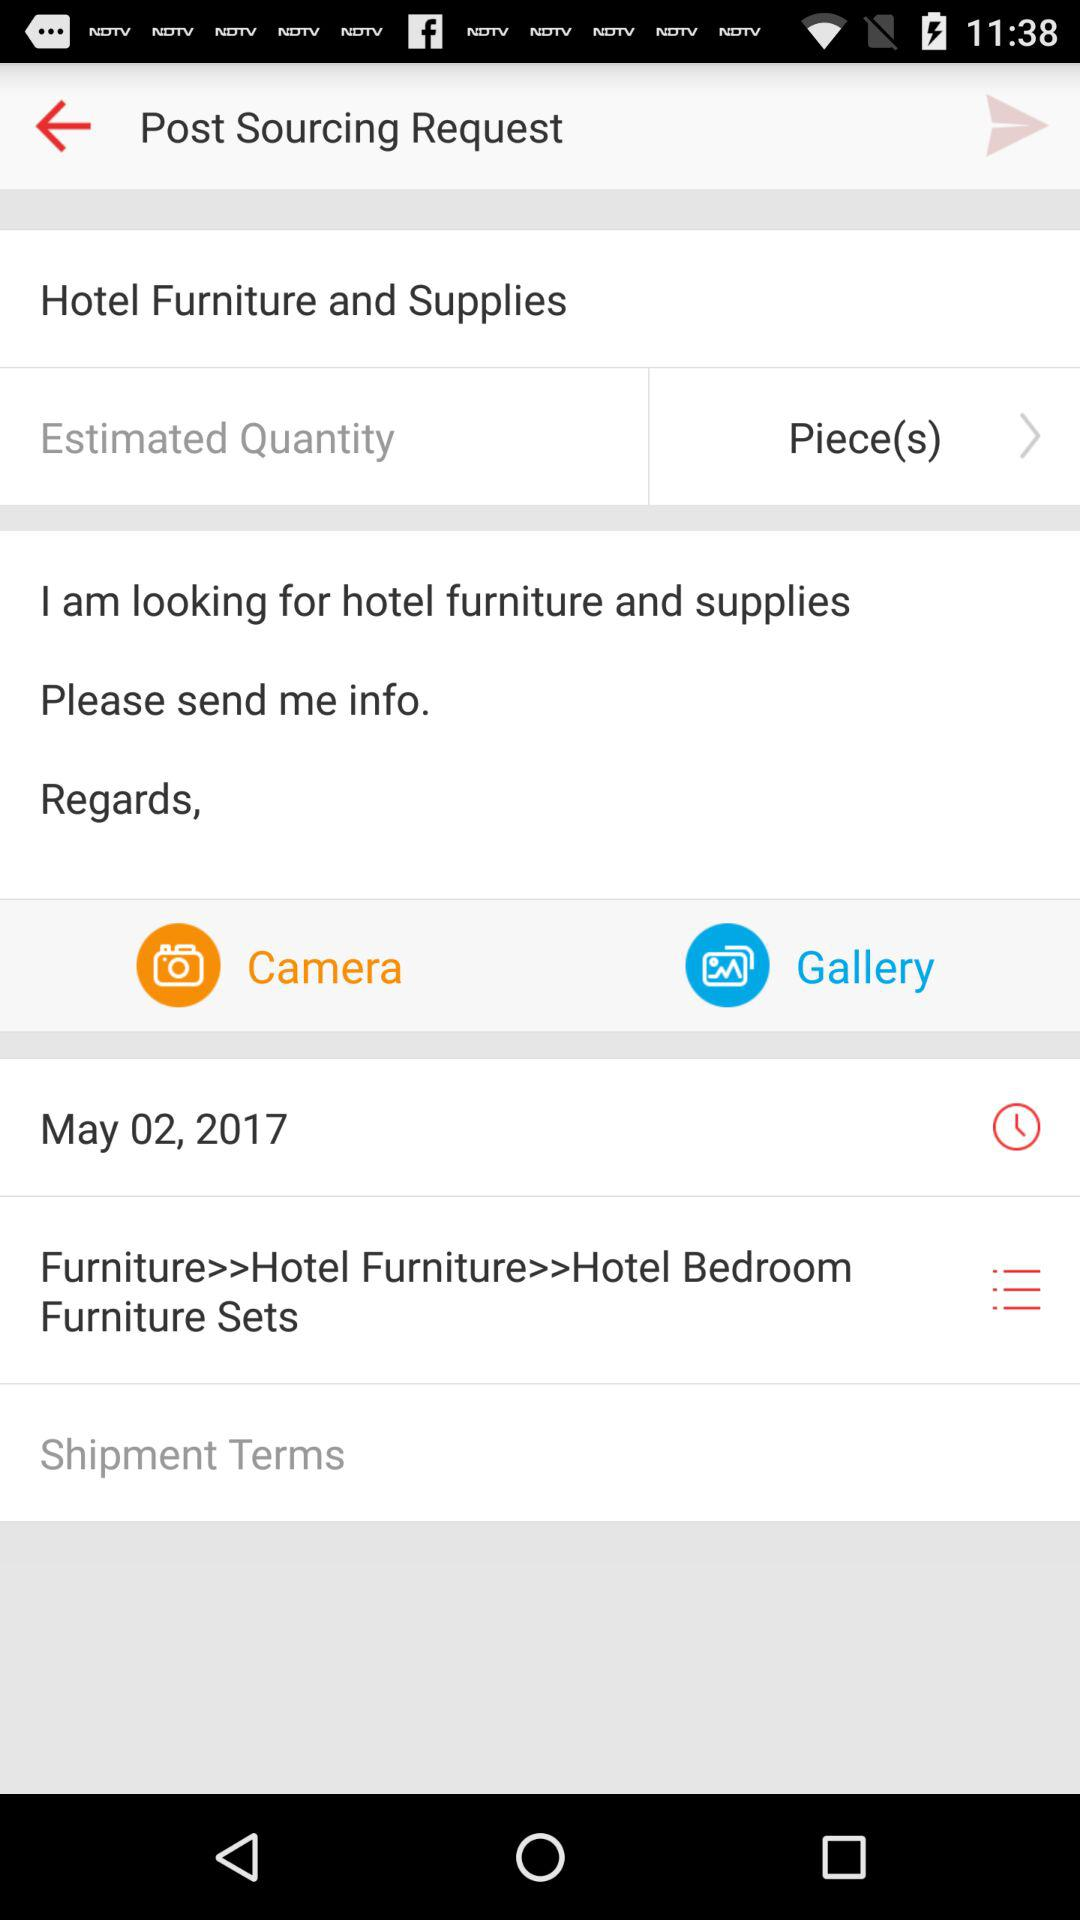Which thing is the user looking for? The user is looking for hotel furniture and supplies. 